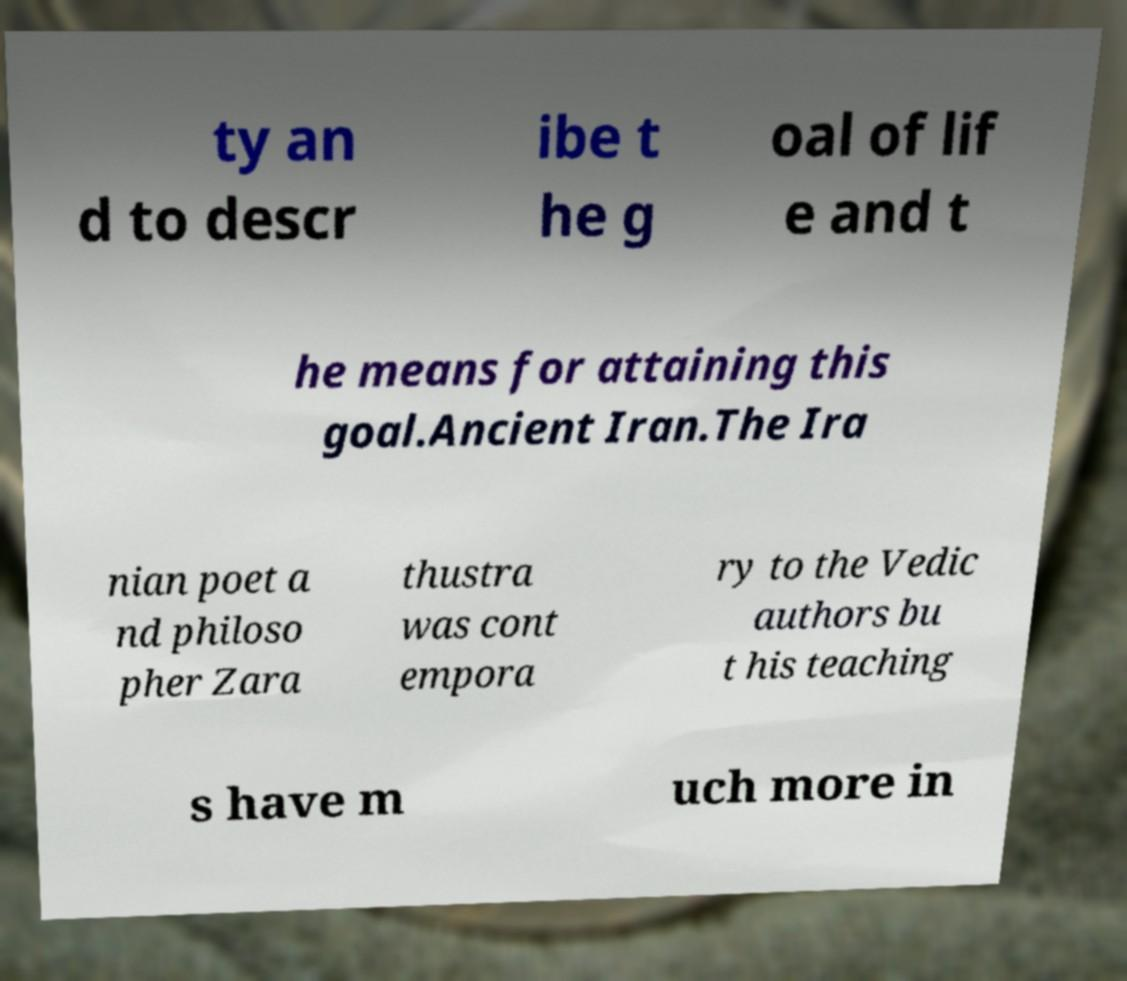Please identify and transcribe the text found in this image. ty an d to descr ibe t he g oal of lif e and t he means for attaining this goal.Ancient Iran.The Ira nian poet a nd philoso pher Zara thustra was cont empora ry to the Vedic authors bu t his teaching s have m uch more in 